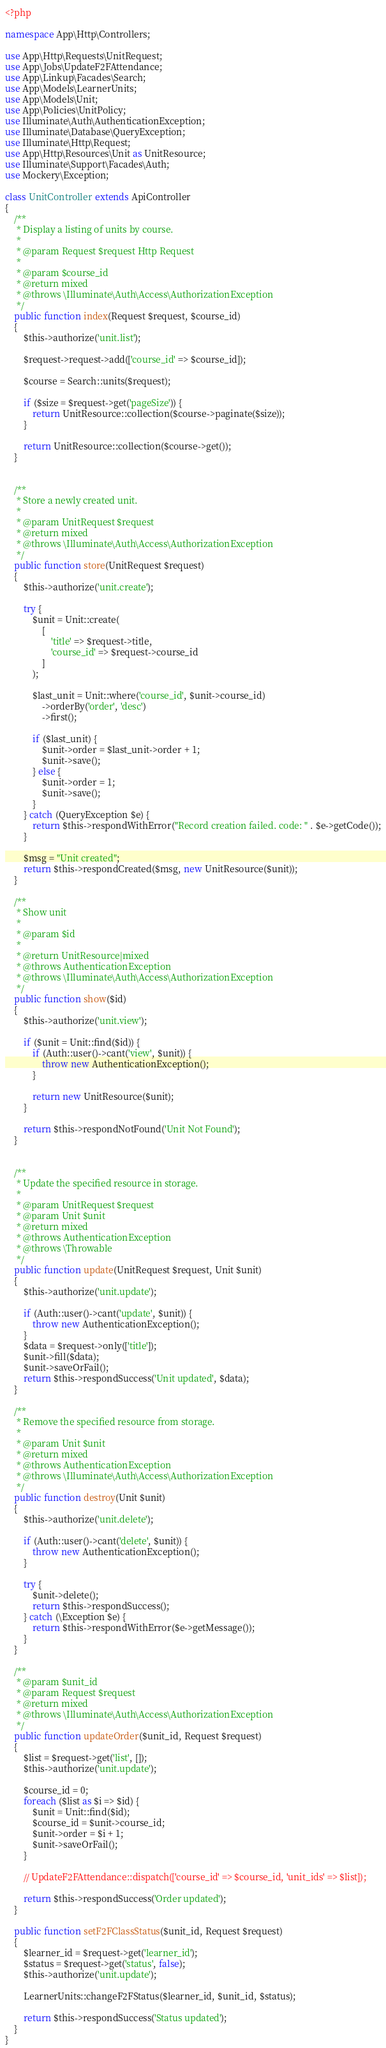Convert code to text. <code><loc_0><loc_0><loc_500><loc_500><_PHP_><?php

namespace App\Http\Controllers;

use App\Http\Requests\UnitRequest;
use App\Jobs\UpdateF2FAttendance;
use App\Linkup\Facades\Search;
use App\Models\LearnerUnits;
use App\Models\Unit;
use App\Policies\UnitPolicy;
use Illuminate\Auth\AuthenticationException;
use Illuminate\Database\QueryException;
use Illuminate\Http\Request;
use App\Http\Resources\Unit as UnitResource;
use Illuminate\Support\Facades\Auth;
use Mockery\Exception;

class UnitController extends ApiController
{
    /**
     * Display a listing of units by course.
     *
     * @param Request $request Http Request
     *
     * @param $course_id
     * @return mixed
     * @throws \Illuminate\Auth\Access\AuthorizationException
     */
    public function index(Request $request, $course_id)
    {
        $this->authorize('unit.list');

        $request->request->add(['course_id' => $course_id]);

        $course = Search::units($request);

        if ($size = $request->get('pageSize')) {
            return UnitResource::collection($course->paginate($size));
        }

        return UnitResource::collection($course->get());
    }


    /**
     * Store a newly created unit.
     *
     * @param UnitRequest $request
     * @return mixed
     * @throws \Illuminate\Auth\Access\AuthorizationException
     */
    public function store(UnitRequest $request)
    {
        $this->authorize('unit.create');

        try {
            $unit = Unit::create(
                [
                    'title' => $request->title,
                    'course_id' => $request->course_id
                ]
            );

            $last_unit = Unit::where('course_id', $unit->course_id)
                ->orderBy('order', 'desc')
                ->first();

            if ($last_unit) {
                $unit->order = $last_unit->order + 1;
                $unit->save();
            } else {
                $unit->order = 1;
                $unit->save();
            }
        } catch (QueryException $e) {
            return $this->respondWithError("Record creation failed. code: " . $e->getCode());
        }

        $msg = "Unit created";
        return $this->respondCreated($msg, new UnitResource($unit));
    }

    /**
     * Show unit
     *
     * @param $id
     *
     * @return UnitResource|mixed
     * @throws AuthenticationException
     * @throws \Illuminate\Auth\Access\AuthorizationException
     */
    public function show($id)
    {
        $this->authorize('unit.view');

        if ($unit = Unit::find($id)) {
            if (Auth::user()->cant('view', $unit)) {
                throw new AuthenticationException();
            }

            return new UnitResource($unit);
        }

        return $this->respondNotFound('Unit Not Found');
    }


    /**
     * Update the specified resource in storage.
     *
     * @param UnitRequest $request
     * @param Unit $unit
     * @return mixed
     * @throws AuthenticationException
     * @throws \Throwable
     */
    public function update(UnitRequest $request, Unit $unit)
    {
        $this->authorize('unit.update');

        if (Auth::user()->cant('update', $unit)) {
            throw new AuthenticationException();
        }
        $data = $request->only(['title']);
        $unit->fill($data);
        $unit->saveOrFail();
        return $this->respondSuccess('Unit updated', $data);
    }

    /**
     * Remove the specified resource from storage.
     *
     * @param Unit $unit
     * @return mixed
     * @throws AuthenticationException
     * @throws \Illuminate\Auth\Access\AuthorizationException
     */
    public function destroy(Unit $unit)
    {
        $this->authorize('unit.delete');

        if (Auth::user()->cant('delete', $unit)) {
            throw new AuthenticationException();
        }

        try {
            $unit->delete();
            return $this->respondSuccess();
        } catch (\Exception $e) {
            return $this->respondWithError($e->getMessage());
        }
    }

    /**
     * @param $unit_id
     * @param Request $request
     * @return mixed
     * @throws \Illuminate\Auth\Access\AuthorizationException
     */
    public function updateOrder($unit_id, Request $request)
    {
        $list = $request->get('list', []);
        $this->authorize('unit.update');

        $course_id = 0;
        foreach ($list as $i => $id) {
            $unit = Unit::find($id);
            $course_id = $unit->course_id;
            $unit->order = $i + 1;
            $unit->saveOrFail();
        }

        // UpdateF2FAttendance::dispatch(['course_id' => $course_id, 'unit_ids' => $list]);

        return $this->respondSuccess('Order updated');
    }

    public function setF2FClassStatus($unit_id, Request $request)
    {
        $learner_id = $request->get('learner_id');
        $status = $request->get('status', false);
        $this->authorize('unit.update');

        LearnerUnits::changeF2FStatus($learner_id, $unit_id, $status);

        return $this->respondSuccess('Status updated');
    }
}
</code> 